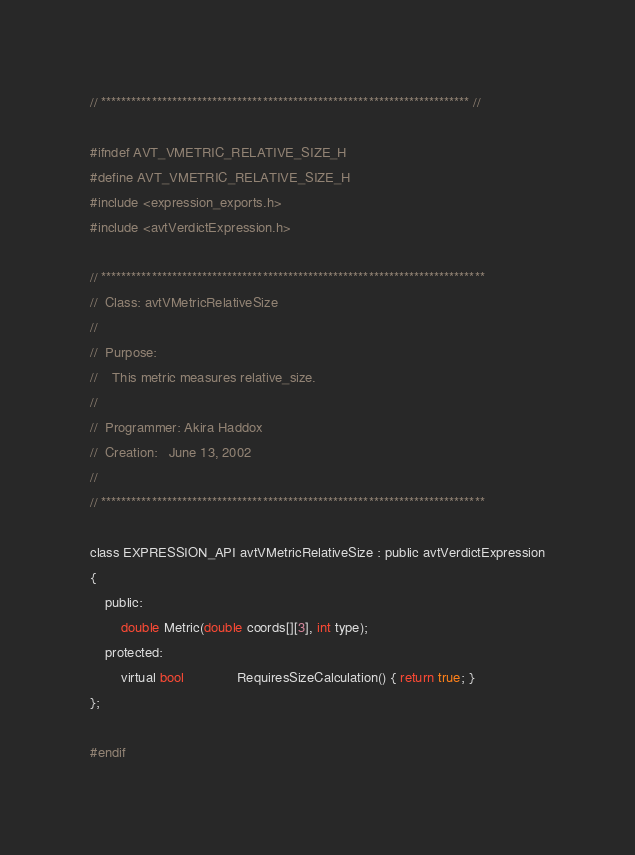<code> <loc_0><loc_0><loc_500><loc_500><_C_>// ************************************************************************* //

#ifndef AVT_VMETRIC_RELATIVE_SIZE_H
#define AVT_VMETRIC_RELATIVE_SIZE_H
#include <expression_exports.h>
#include <avtVerdictExpression.h>

// ****************************************************************************
//  Class: avtVMetricRelativeSize
//
//  Purpose:
//    This metric measures relative_size.
//
//  Programmer: Akira Haddox
//  Creation:   June 13, 2002
//
// ****************************************************************************

class EXPRESSION_API avtVMetricRelativeSize : public avtVerdictExpression
{
    public:
        double Metric(double coords[][3], int type);
    protected:
        virtual bool              RequiresSizeCalculation() { return true; }
};

#endif


</code> 